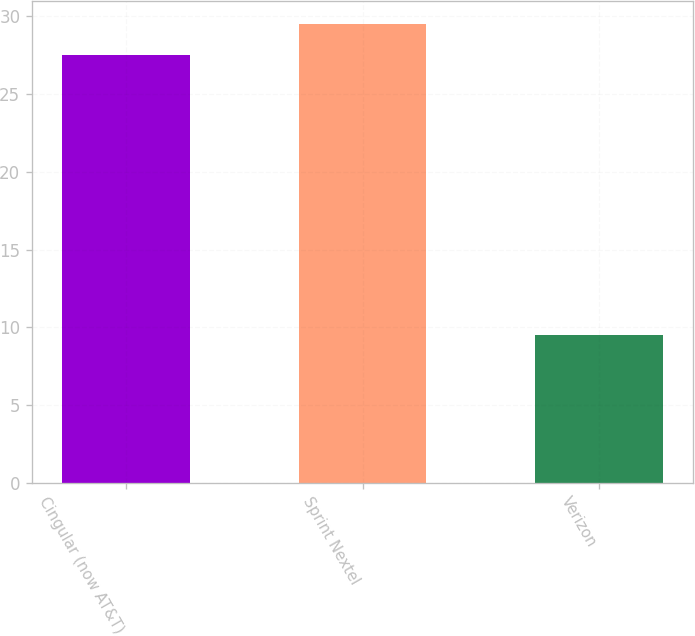<chart> <loc_0><loc_0><loc_500><loc_500><bar_chart><fcel>Cingular (now AT&T)<fcel>Sprint Nextel<fcel>Verizon<nl><fcel>27.5<fcel>29.49<fcel>9.5<nl></chart> 